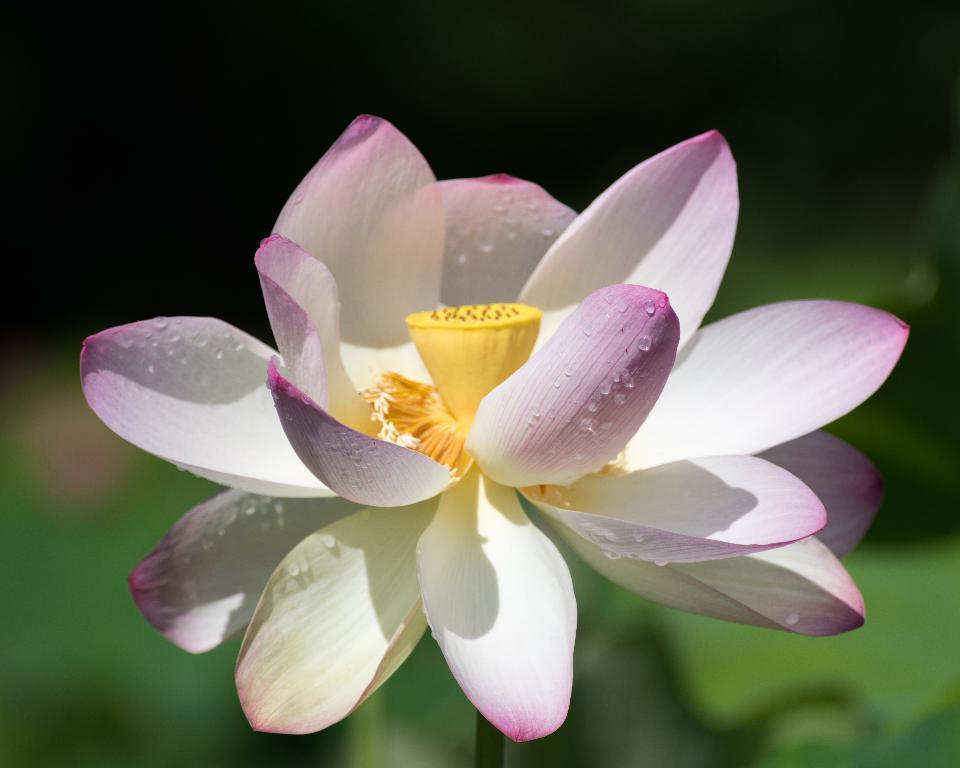Describe this image in one or two sentences. In the center of the picture there is a flower. The petals are white and violet in color, on the petals there are water droplets. The background is blurred. 